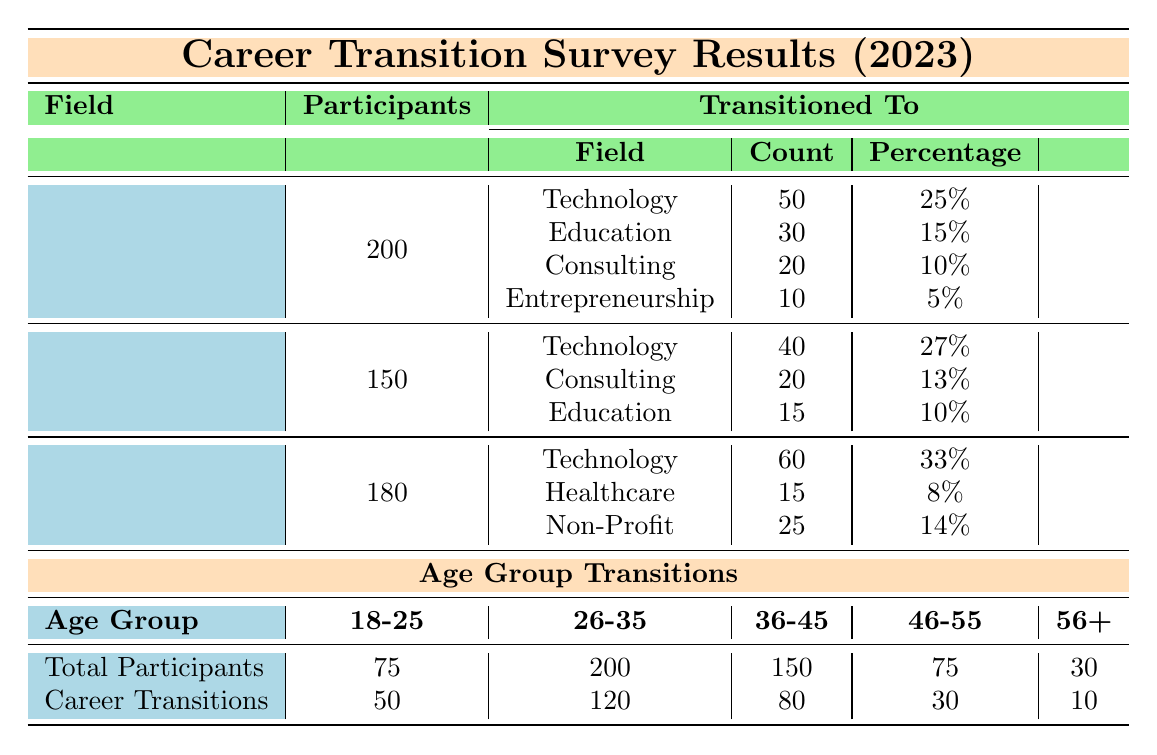What percentage of Healthcare participants transitioned to Technology? In the Healthcare field, 50 participants transitioned to Technology out of 200 total participants. To find the percentage, divide 50 by 200 and multiply by 100. (50/200) * 100 = 25%.
Answer: 25% What is the total number of participants who transitioned from Education to another field? In the Education field, the table lists 3 transitions with counts of 60 (Technology), 15 (Healthcare), and 25 (Non-Profit). Adding these counts gives 60 + 15 + 25 = 100.
Answer: 100 Which field had the highest percentage of transitions to Technology? Examining the transition percentages to Technology: Healthcare has 25%, Finance has 27%, and Education has 33%. The highest percentage is from Education at 33%.
Answer: Education Is there a greater number of participants transitioning from Finance to Technology or from Healthcare to Education? The count of transitions from Finance to Technology is 40, while the count from Healthcare to Education is 30. Since 40 is greater than 30, the result is that Finance had more transitions to Technology.
Answer: Yes What is the total number of career transitions across all fields? The total number of career transitions consists of summing all transition counts from each field. For Healthcare: 50 + 30 + 20 + 10 = 110. For Finance: 40 + 20 + 15 = 75. For Education: 60 + 15 + 25 = 100. Adding all these gives 110 + 75 + 100 = 285.
Answer: 285 What is the average number of career transitions for the age group 26-35? Total participants in the age group 26-35 is 200, with 120 career transitions. The average is calculated by dividing the total transitions by the total participants (120/200) which gives an average of 0.6 transitions per participant.
Answer: 0.6 Which age group had the least number of career transitions? Checking each age group: 18-25 had 50, 26-35 had 120, 36-45 had 80, 46-55 had 30, and 56+ had 10 transitions. The 56+ age group has the least transitions at 10.
Answer: 56+ How many participants aged 46-55 transitioned compared to those aged 18-25? The 46-55 age group has 30 career transitions, while the 18-25 age group has 50. Comparing both counts shows that 30 is less than 50.
Answer: No What is the percentage of career transitions for the age group 36-45? In the 36-45 age group, there are 80 career transitions out of 150 total participants. To find the percentage, divide 80 by 150 and multiply by 100. (80/150) * 100 = 53.33%.
Answer: 53.33% How many more participants transitioned from Healthcare to Education than from Finance to Consulting? The number of transitions from Healthcare to Education is 30, and from Finance to Consulting is 20. The difference is 30 - 20 = 10 more participants transitioned from Healthcare to Education.
Answer: 10 more 